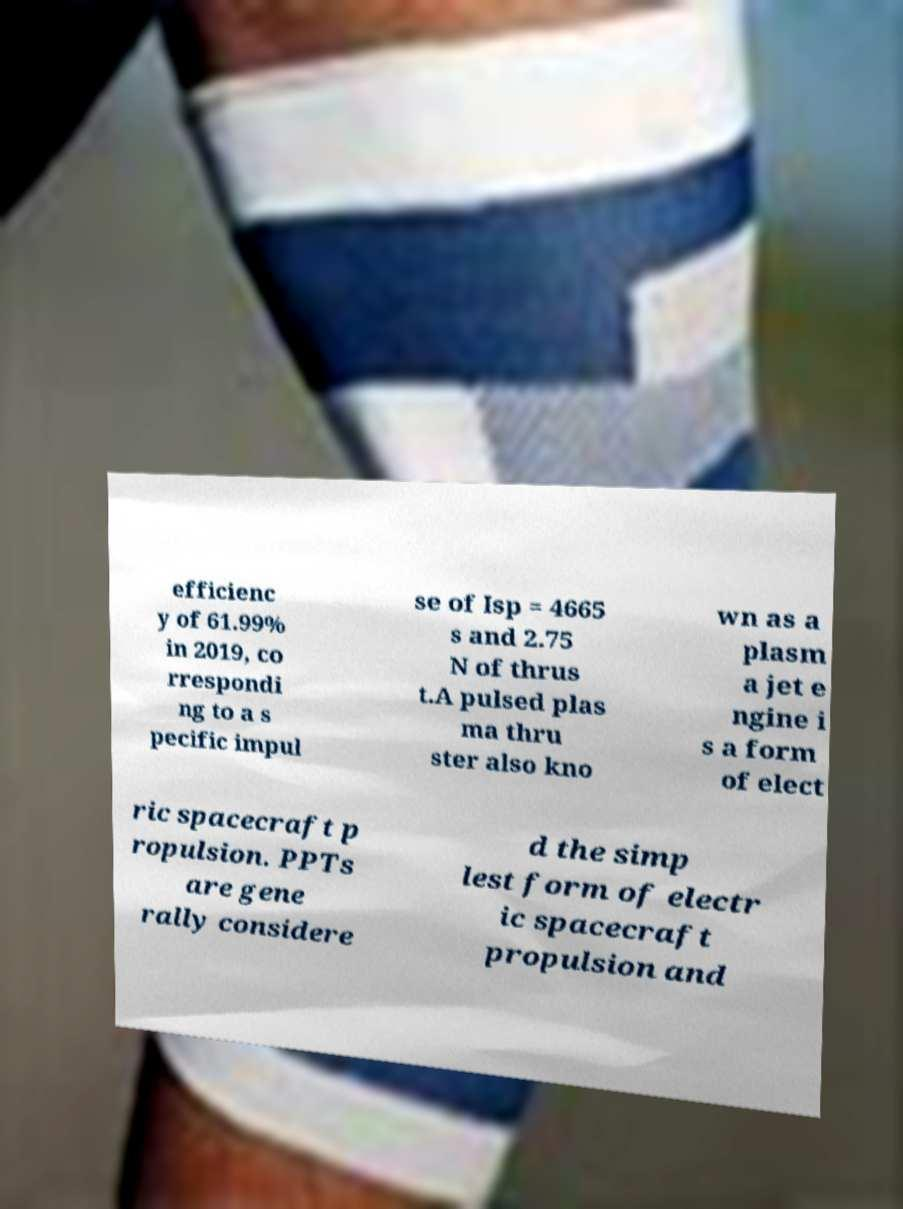There's text embedded in this image that I need extracted. Can you transcribe it verbatim? efficienc y of 61.99% in 2019, co rrespondi ng to a s pecific impul se of Isp = 4665 s and 2.75 N of thrus t.A pulsed plas ma thru ster also kno wn as a plasm a jet e ngine i s a form of elect ric spacecraft p ropulsion. PPTs are gene rally considere d the simp lest form of electr ic spacecraft propulsion and 